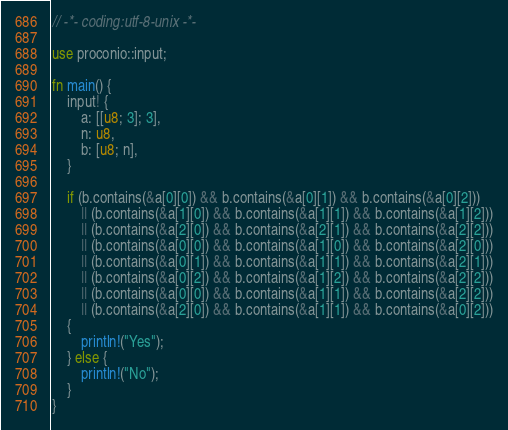Convert code to text. <code><loc_0><loc_0><loc_500><loc_500><_Rust_>// -*- coding:utf-8-unix -*-

use proconio::input;

fn main() {
    input! {
        a: [[u8; 3]; 3],
        n: u8,
        b: [u8; n],
    }

    if (b.contains(&a[0][0]) && b.contains(&a[0][1]) && b.contains(&a[0][2]))
        || (b.contains(&a[1][0]) && b.contains(&a[1][1]) && b.contains(&a[1][2]))
        || (b.contains(&a[2][0]) && b.contains(&a[2][1]) && b.contains(&a[2][2]))
        || (b.contains(&a[0][0]) && b.contains(&a[1][0]) && b.contains(&a[2][0]))
        || (b.contains(&a[0][1]) && b.contains(&a[1][1]) && b.contains(&a[2][1]))
        || (b.contains(&a[0][2]) && b.contains(&a[1][2]) && b.contains(&a[2][2]))
        || (b.contains(&a[0][0]) && b.contains(&a[1][1]) && b.contains(&a[2][2]))
        || (b.contains(&a[2][0]) && b.contains(&a[1][1]) && b.contains(&a[0][2]))
    {
        println!("Yes");
    } else {
        println!("No");
    }
}
</code> 